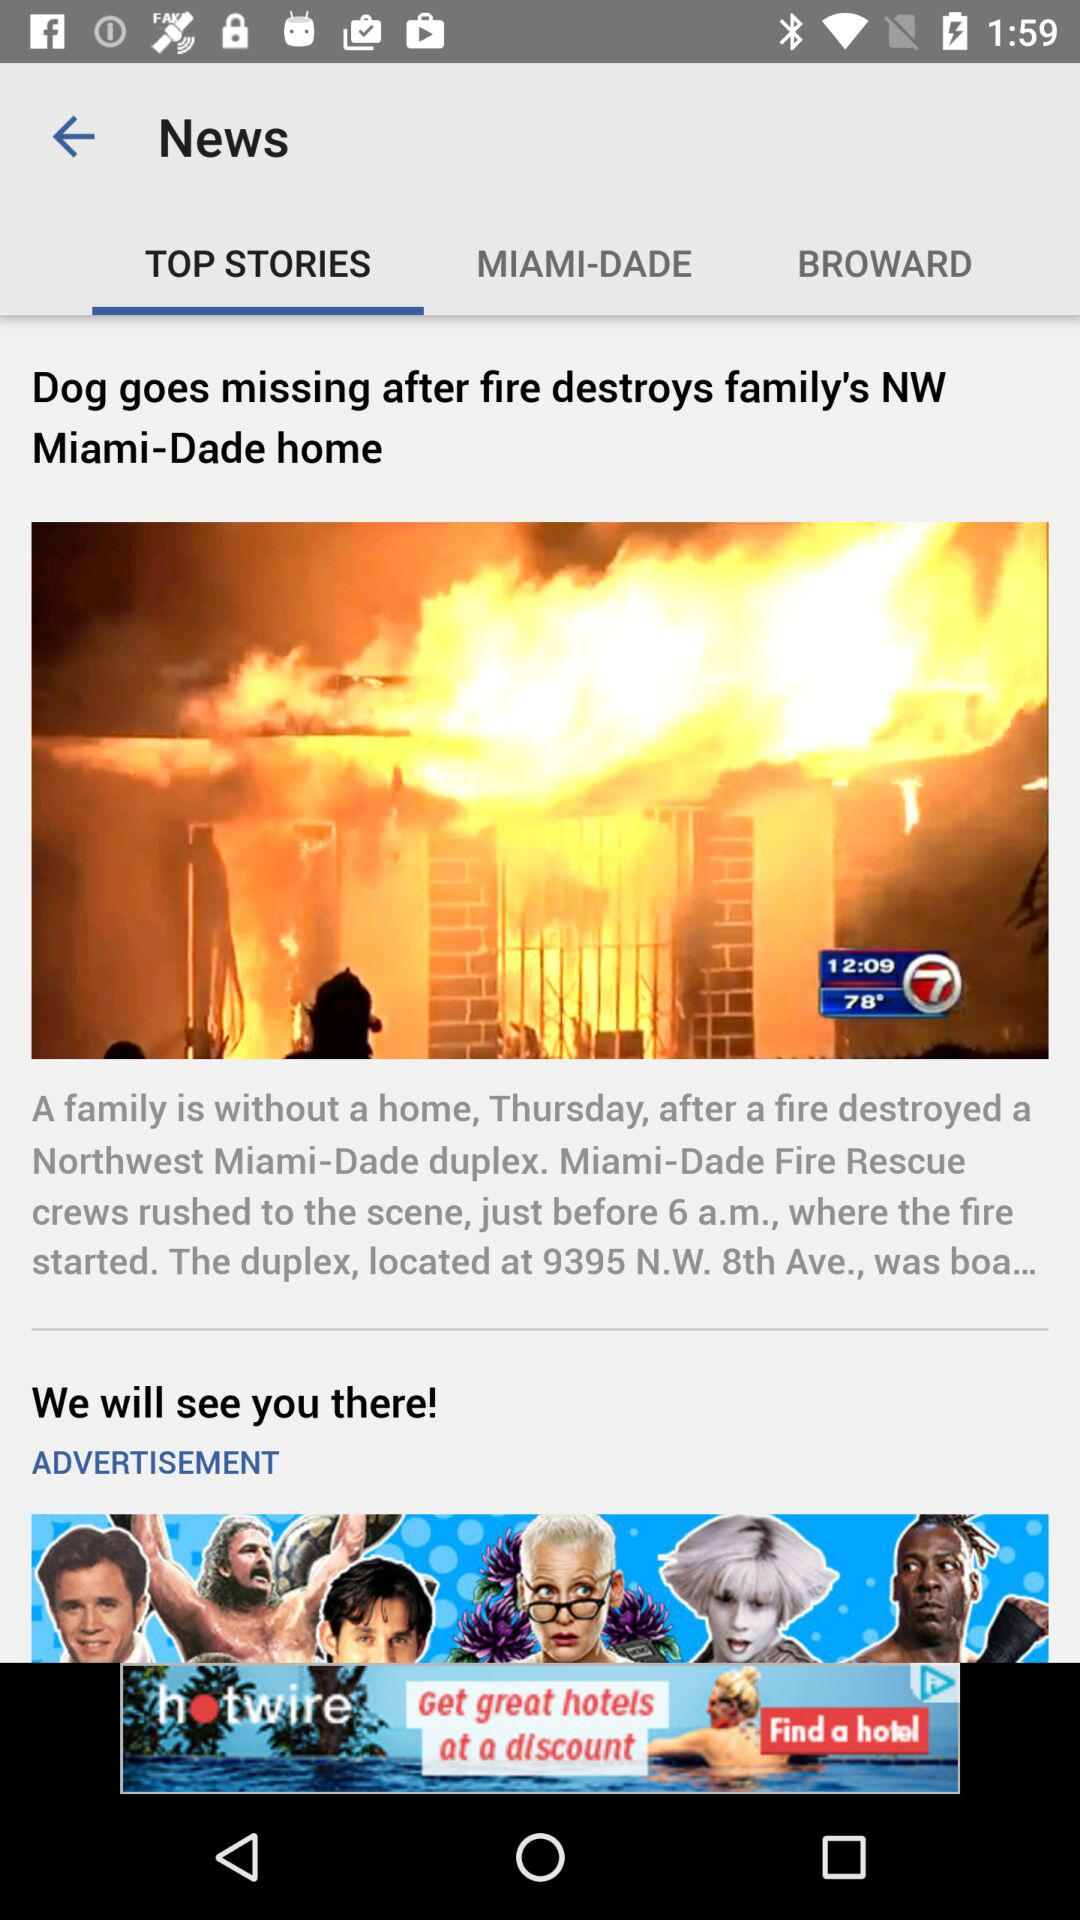At what time did the fire rescue team reach the spot? The fire rescue team reached the spot just before 6 a.m. 